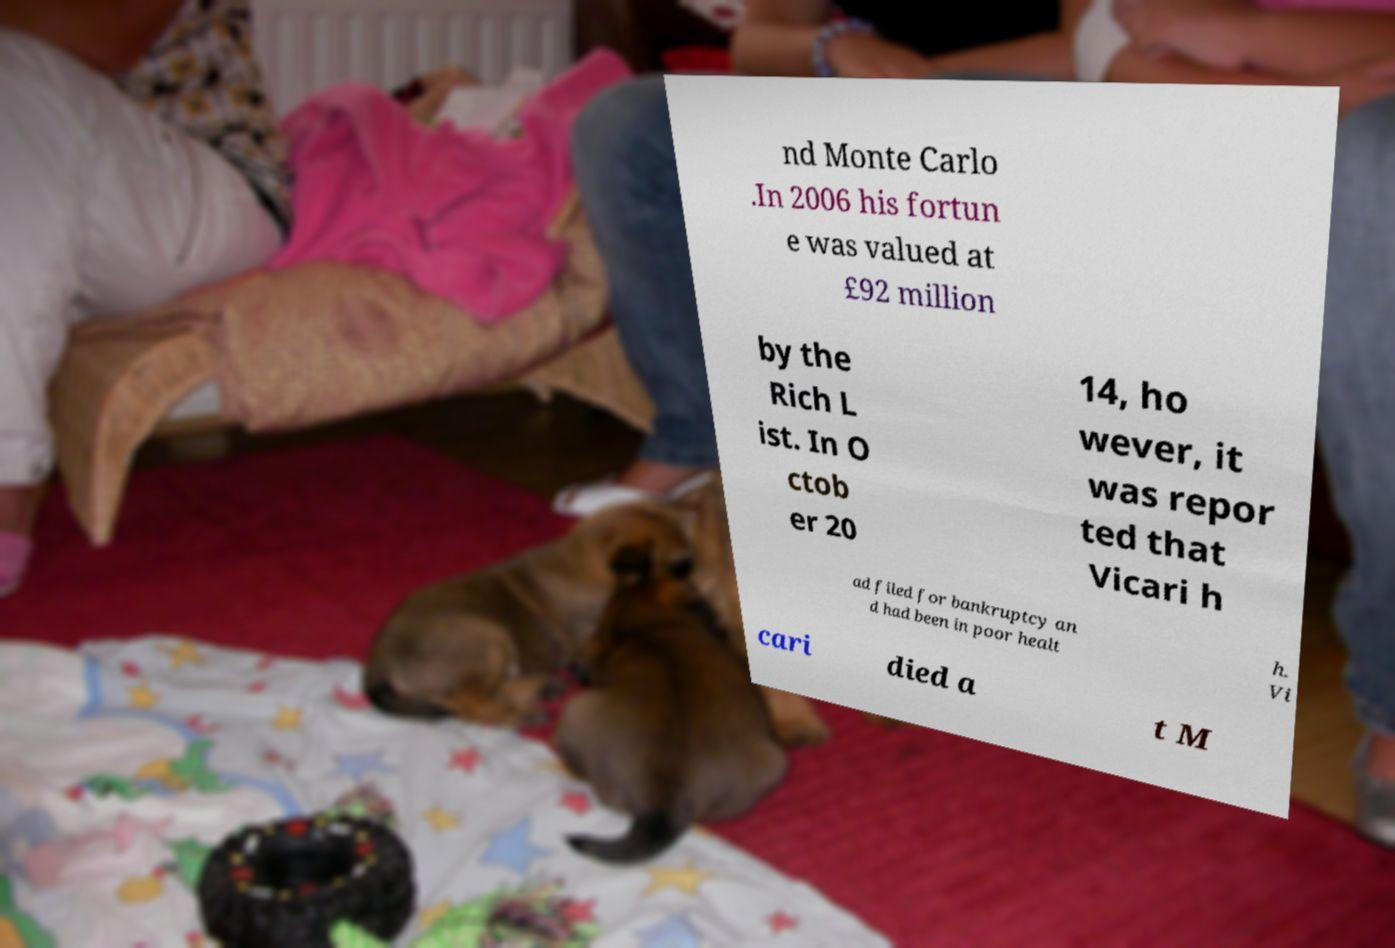Please read and relay the text visible in this image. What does it say? nd Monte Carlo .In 2006 his fortun e was valued at £92 million by the Rich L ist. In O ctob er 20 14, ho wever, it was repor ted that Vicari h ad filed for bankruptcy an d had been in poor healt h. Vi cari died a t M 